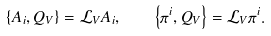Convert formula to latex. <formula><loc_0><loc_0><loc_500><loc_500>\left \{ A _ { i } , Q _ { V } \right \} = \mathcal { L } _ { V } A _ { i } , \quad \left \{ \pi ^ { i } , Q _ { V } \right \} = \mathcal { L } _ { V } \pi ^ { i } .</formula> 